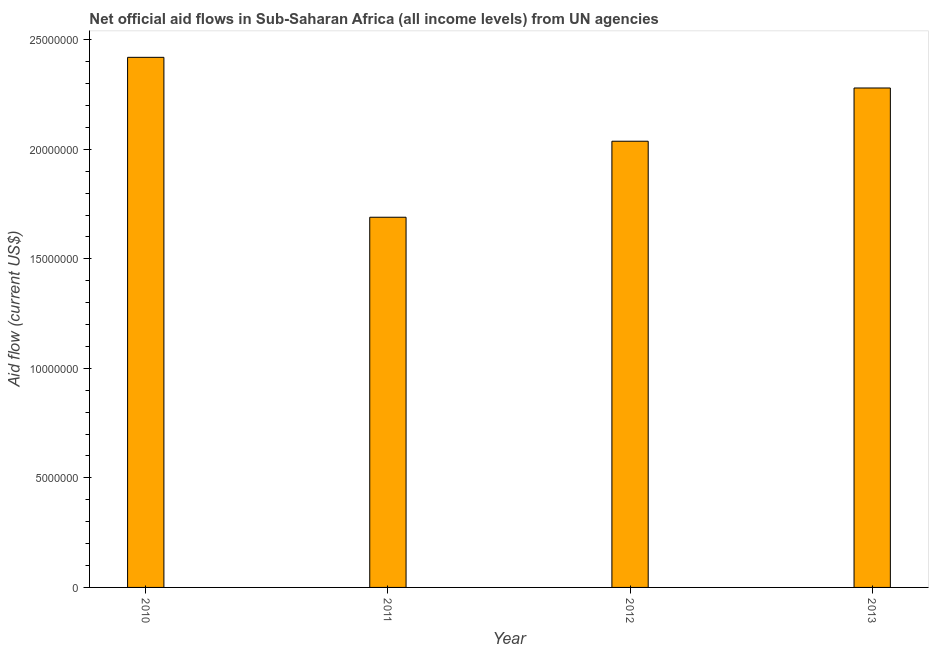Does the graph contain any zero values?
Give a very brief answer. No. What is the title of the graph?
Provide a short and direct response. Net official aid flows in Sub-Saharan Africa (all income levels) from UN agencies. What is the label or title of the X-axis?
Offer a very short reply. Year. What is the label or title of the Y-axis?
Offer a terse response. Aid flow (current US$). What is the net official flows from un agencies in 2013?
Provide a short and direct response. 2.28e+07. Across all years, what is the maximum net official flows from un agencies?
Your answer should be very brief. 2.42e+07. Across all years, what is the minimum net official flows from un agencies?
Offer a terse response. 1.69e+07. In which year was the net official flows from un agencies maximum?
Provide a succinct answer. 2010. What is the sum of the net official flows from un agencies?
Your answer should be very brief. 8.43e+07. What is the difference between the net official flows from un agencies in 2010 and 2012?
Offer a terse response. 3.83e+06. What is the average net official flows from un agencies per year?
Offer a terse response. 2.11e+07. What is the median net official flows from un agencies?
Provide a short and direct response. 2.16e+07. In how many years, is the net official flows from un agencies greater than 10000000 US$?
Offer a very short reply. 4. What is the ratio of the net official flows from un agencies in 2010 to that in 2012?
Provide a succinct answer. 1.19. Is the net official flows from un agencies in 2011 less than that in 2012?
Your response must be concise. Yes. What is the difference between the highest and the second highest net official flows from un agencies?
Ensure brevity in your answer.  1.40e+06. What is the difference between the highest and the lowest net official flows from un agencies?
Your answer should be compact. 7.30e+06. How many bars are there?
Provide a succinct answer. 4. How many years are there in the graph?
Ensure brevity in your answer.  4. What is the difference between two consecutive major ticks on the Y-axis?
Give a very brief answer. 5.00e+06. Are the values on the major ticks of Y-axis written in scientific E-notation?
Offer a very short reply. No. What is the Aid flow (current US$) in 2010?
Give a very brief answer. 2.42e+07. What is the Aid flow (current US$) of 2011?
Ensure brevity in your answer.  1.69e+07. What is the Aid flow (current US$) of 2012?
Make the answer very short. 2.04e+07. What is the Aid flow (current US$) in 2013?
Ensure brevity in your answer.  2.28e+07. What is the difference between the Aid flow (current US$) in 2010 and 2011?
Your answer should be compact. 7.30e+06. What is the difference between the Aid flow (current US$) in 2010 and 2012?
Keep it short and to the point. 3.83e+06. What is the difference between the Aid flow (current US$) in 2010 and 2013?
Your answer should be compact. 1.40e+06. What is the difference between the Aid flow (current US$) in 2011 and 2012?
Your answer should be very brief. -3.47e+06. What is the difference between the Aid flow (current US$) in 2011 and 2013?
Provide a short and direct response. -5.90e+06. What is the difference between the Aid flow (current US$) in 2012 and 2013?
Offer a terse response. -2.43e+06. What is the ratio of the Aid flow (current US$) in 2010 to that in 2011?
Keep it short and to the point. 1.43. What is the ratio of the Aid flow (current US$) in 2010 to that in 2012?
Your answer should be very brief. 1.19. What is the ratio of the Aid flow (current US$) in 2010 to that in 2013?
Ensure brevity in your answer.  1.06. What is the ratio of the Aid flow (current US$) in 2011 to that in 2012?
Provide a succinct answer. 0.83. What is the ratio of the Aid flow (current US$) in 2011 to that in 2013?
Offer a very short reply. 0.74. What is the ratio of the Aid flow (current US$) in 2012 to that in 2013?
Provide a short and direct response. 0.89. 